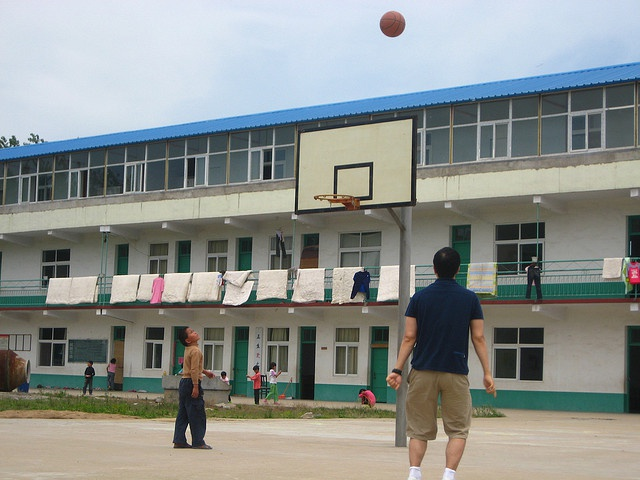Describe the objects in this image and their specific colors. I can see people in lavender, black, and gray tones, people in lavender, black, gray, brown, and maroon tones, people in lavender, black, teal, gray, and darkgray tones, sports ball in lavender, brown, and darkgray tones, and people in lavender, darkgreen, darkgray, and gray tones in this image. 